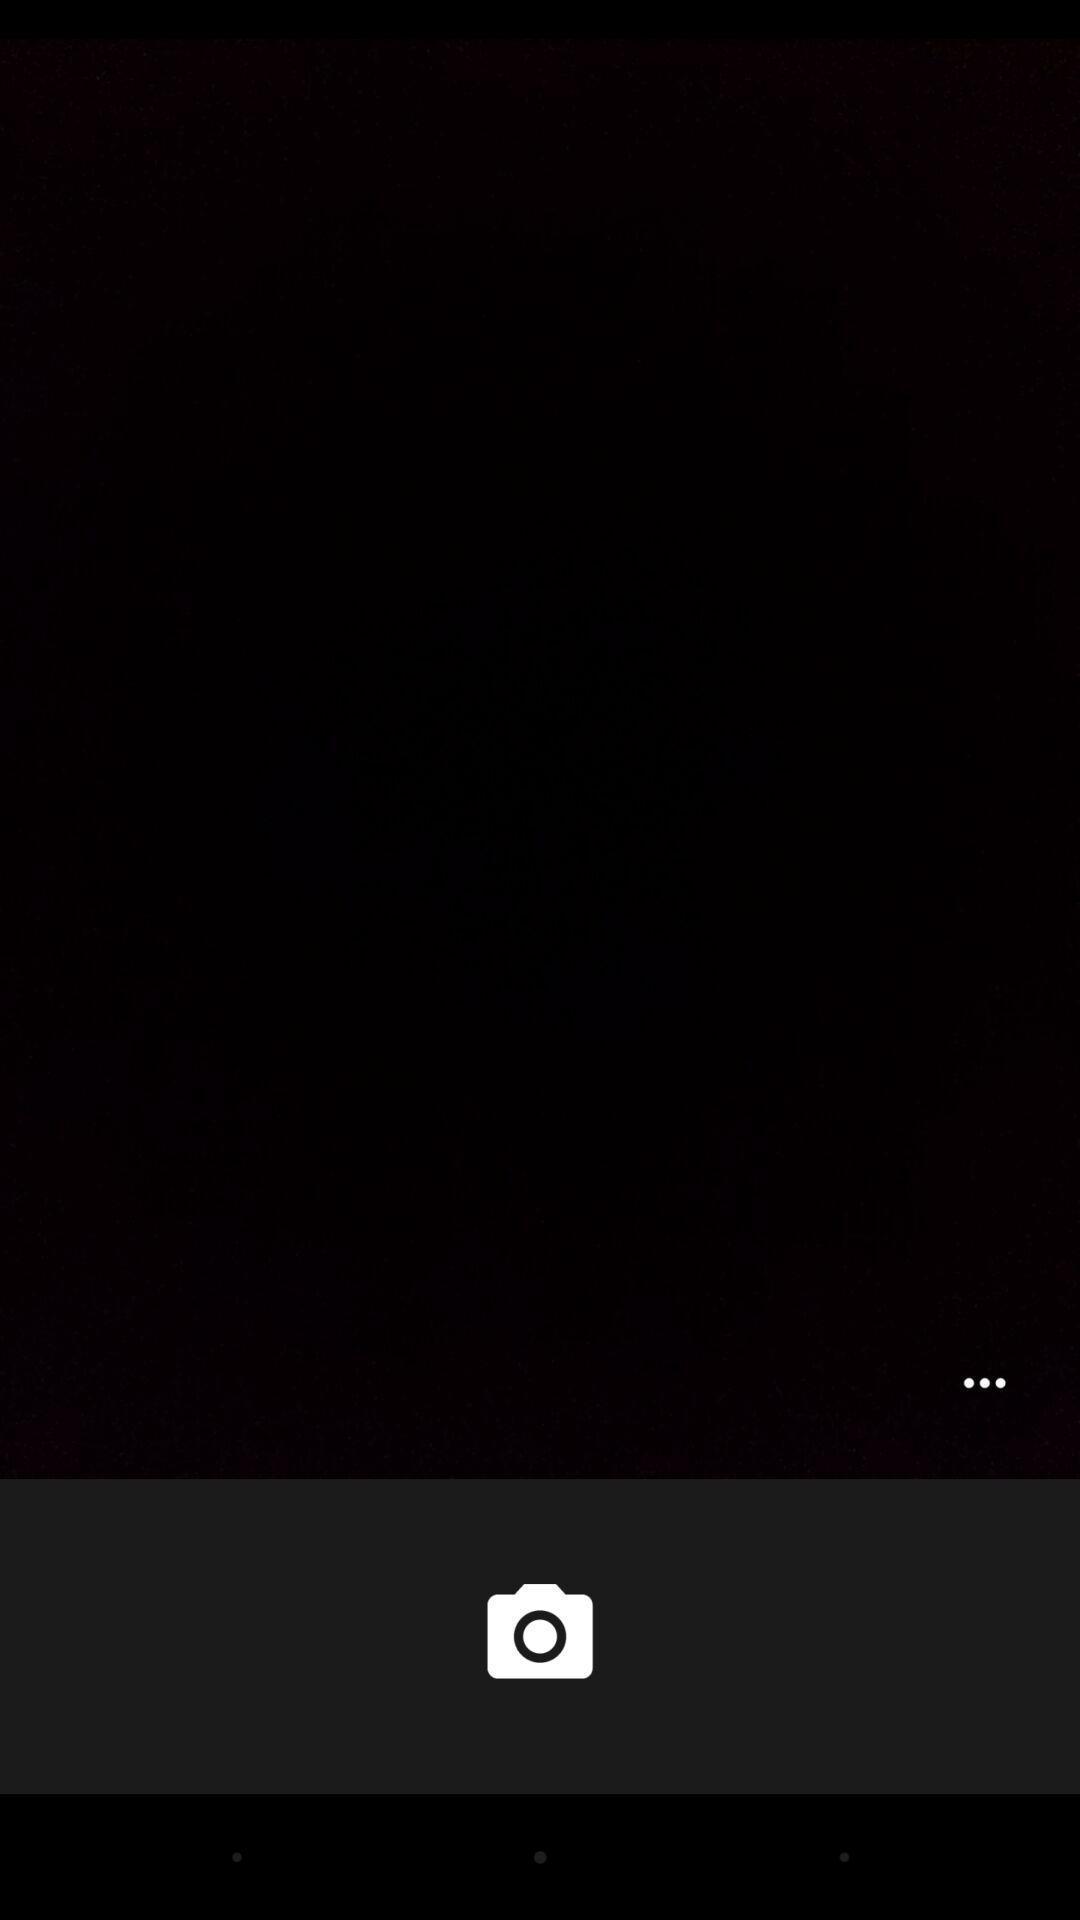What details can you identify in this image? Screen with a camera option. 